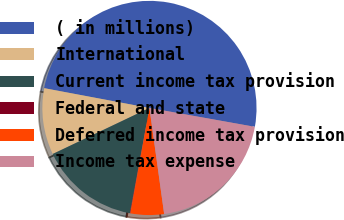<chart> <loc_0><loc_0><loc_500><loc_500><pie_chart><fcel>( in millions)<fcel>International<fcel>Current income tax provision<fcel>Federal and state<fcel>Deferred income tax provision<fcel>Income tax expense<nl><fcel>49.87%<fcel>10.03%<fcel>15.01%<fcel>0.07%<fcel>5.05%<fcel>19.99%<nl></chart> 